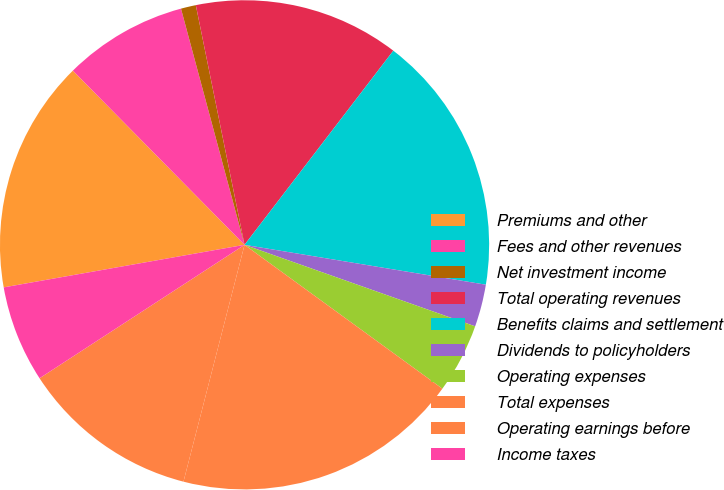Convert chart. <chart><loc_0><loc_0><loc_500><loc_500><pie_chart><fcel>Premiums and other<fcel>Fees and other revenues<fcel>Net investment income<fcel>Total operating revenues<fcel>Benefits claims and settlement<fcel>Dividends to policyholders<fcel>Operating expenses<fcel>Total expenses<fcel>Operating earnings before<fcel>Income taxes<nl><fcel>15.4%<fcel>8.2%<fcel>0.99%<fcel>13.6%<fcel>17.2%<fcel>2.8%<fcel>4.6%<fcel>19.01%<fcel>11.8%<fcel>6.4%<nl></chart> 